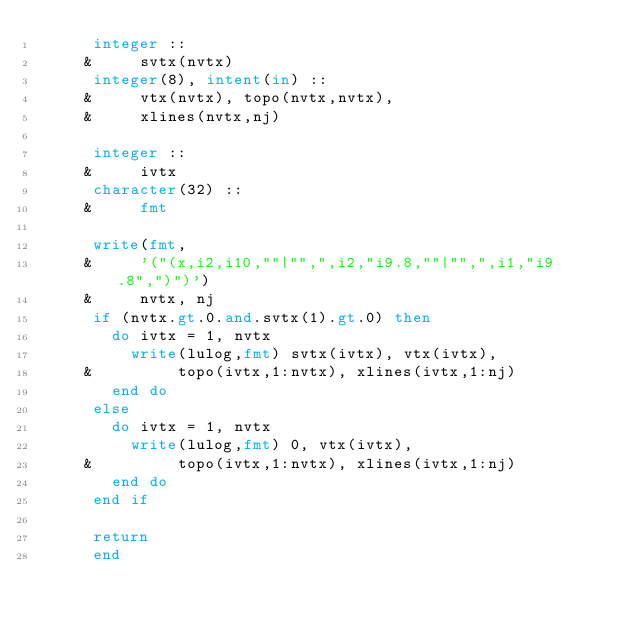Convert code to text. <code><loc_0><loc_0><loc_500><loc_500><_FORTRAN_>      integer ::
     &     svtx(nvtx)
      integer(8), intent(in) ::
     &     vtx(nvtx), topo(nvtx,nvtx),
     &     xlines(nvtx,nj)

      integer ::
     &     ivtx
      character(32) ::
     &     fmt

      write(fmt,
     &     '("(x,i2,i10,""|"",",i2,"i9.8,""|"",",i1,"i9.8",")")')
     &     nvtx, nj
      if (nvtx.gt.0.and.svtx(1).gt.0) then
        do ivtx = 1, nvtx
          write(lulog,fmt) svtx(ivtx), vtx(ivtx),
     &         topo(ivtx,1:nvtx), xlines(ivtx,1:nj)
        end do
      else
        do ivtx = 1, nvtx
          write(lulog,fmt) 0, vtx(ivtx),
     &         topo(ivtx,1:nvtx), xlines(ivtx,1:nj)
        end do
      end if

      return
      end
</code> 